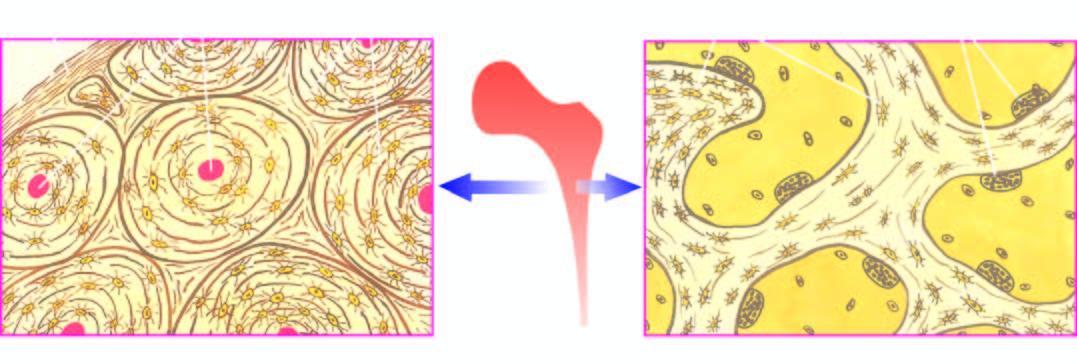how does the trabecular bone forming the marrow space show trabeculae?
Answer the question using a single word or phrase. With osteoclastic activity 